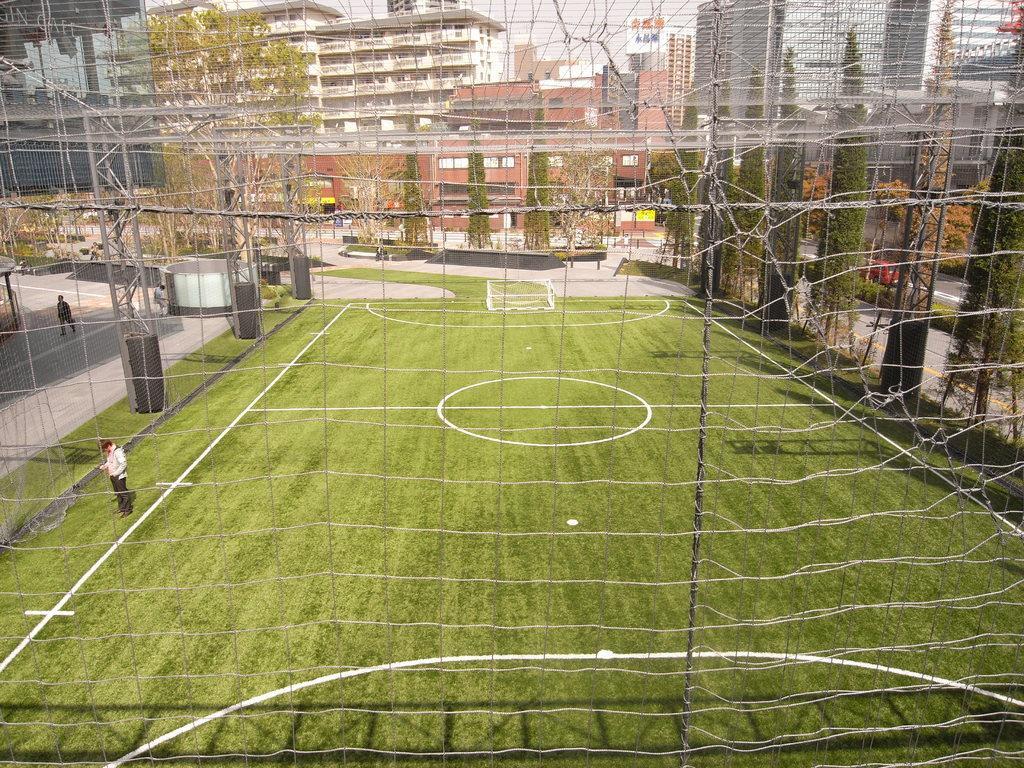In one or two sentences, can you explain what this image depicts? In this picture we can see a person standing on the ground. There is some fencing from left to right. We can see another person walking on the path. There are a few trees and buildings in the background. 